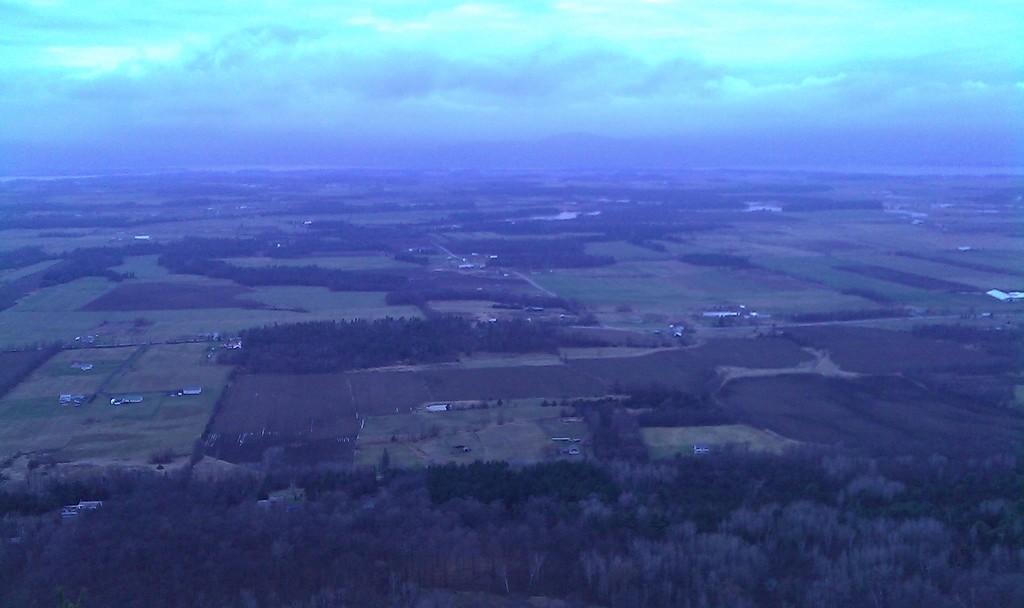Can you describe this image briefly? This is an aerial view where we can see trees, grassy land, buildings and the sky. 